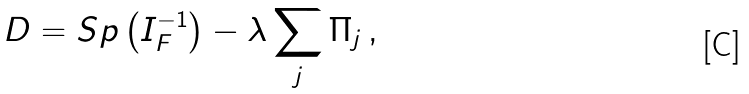Convert formula to latex. <formula><loc_0><loc_0><loc_500><loc_500>D = S p \left ( I _ { F } ^ { - 1 } \right ) - \lambda \sum _ { j } \Pi _ { j } \, ,</formula> 